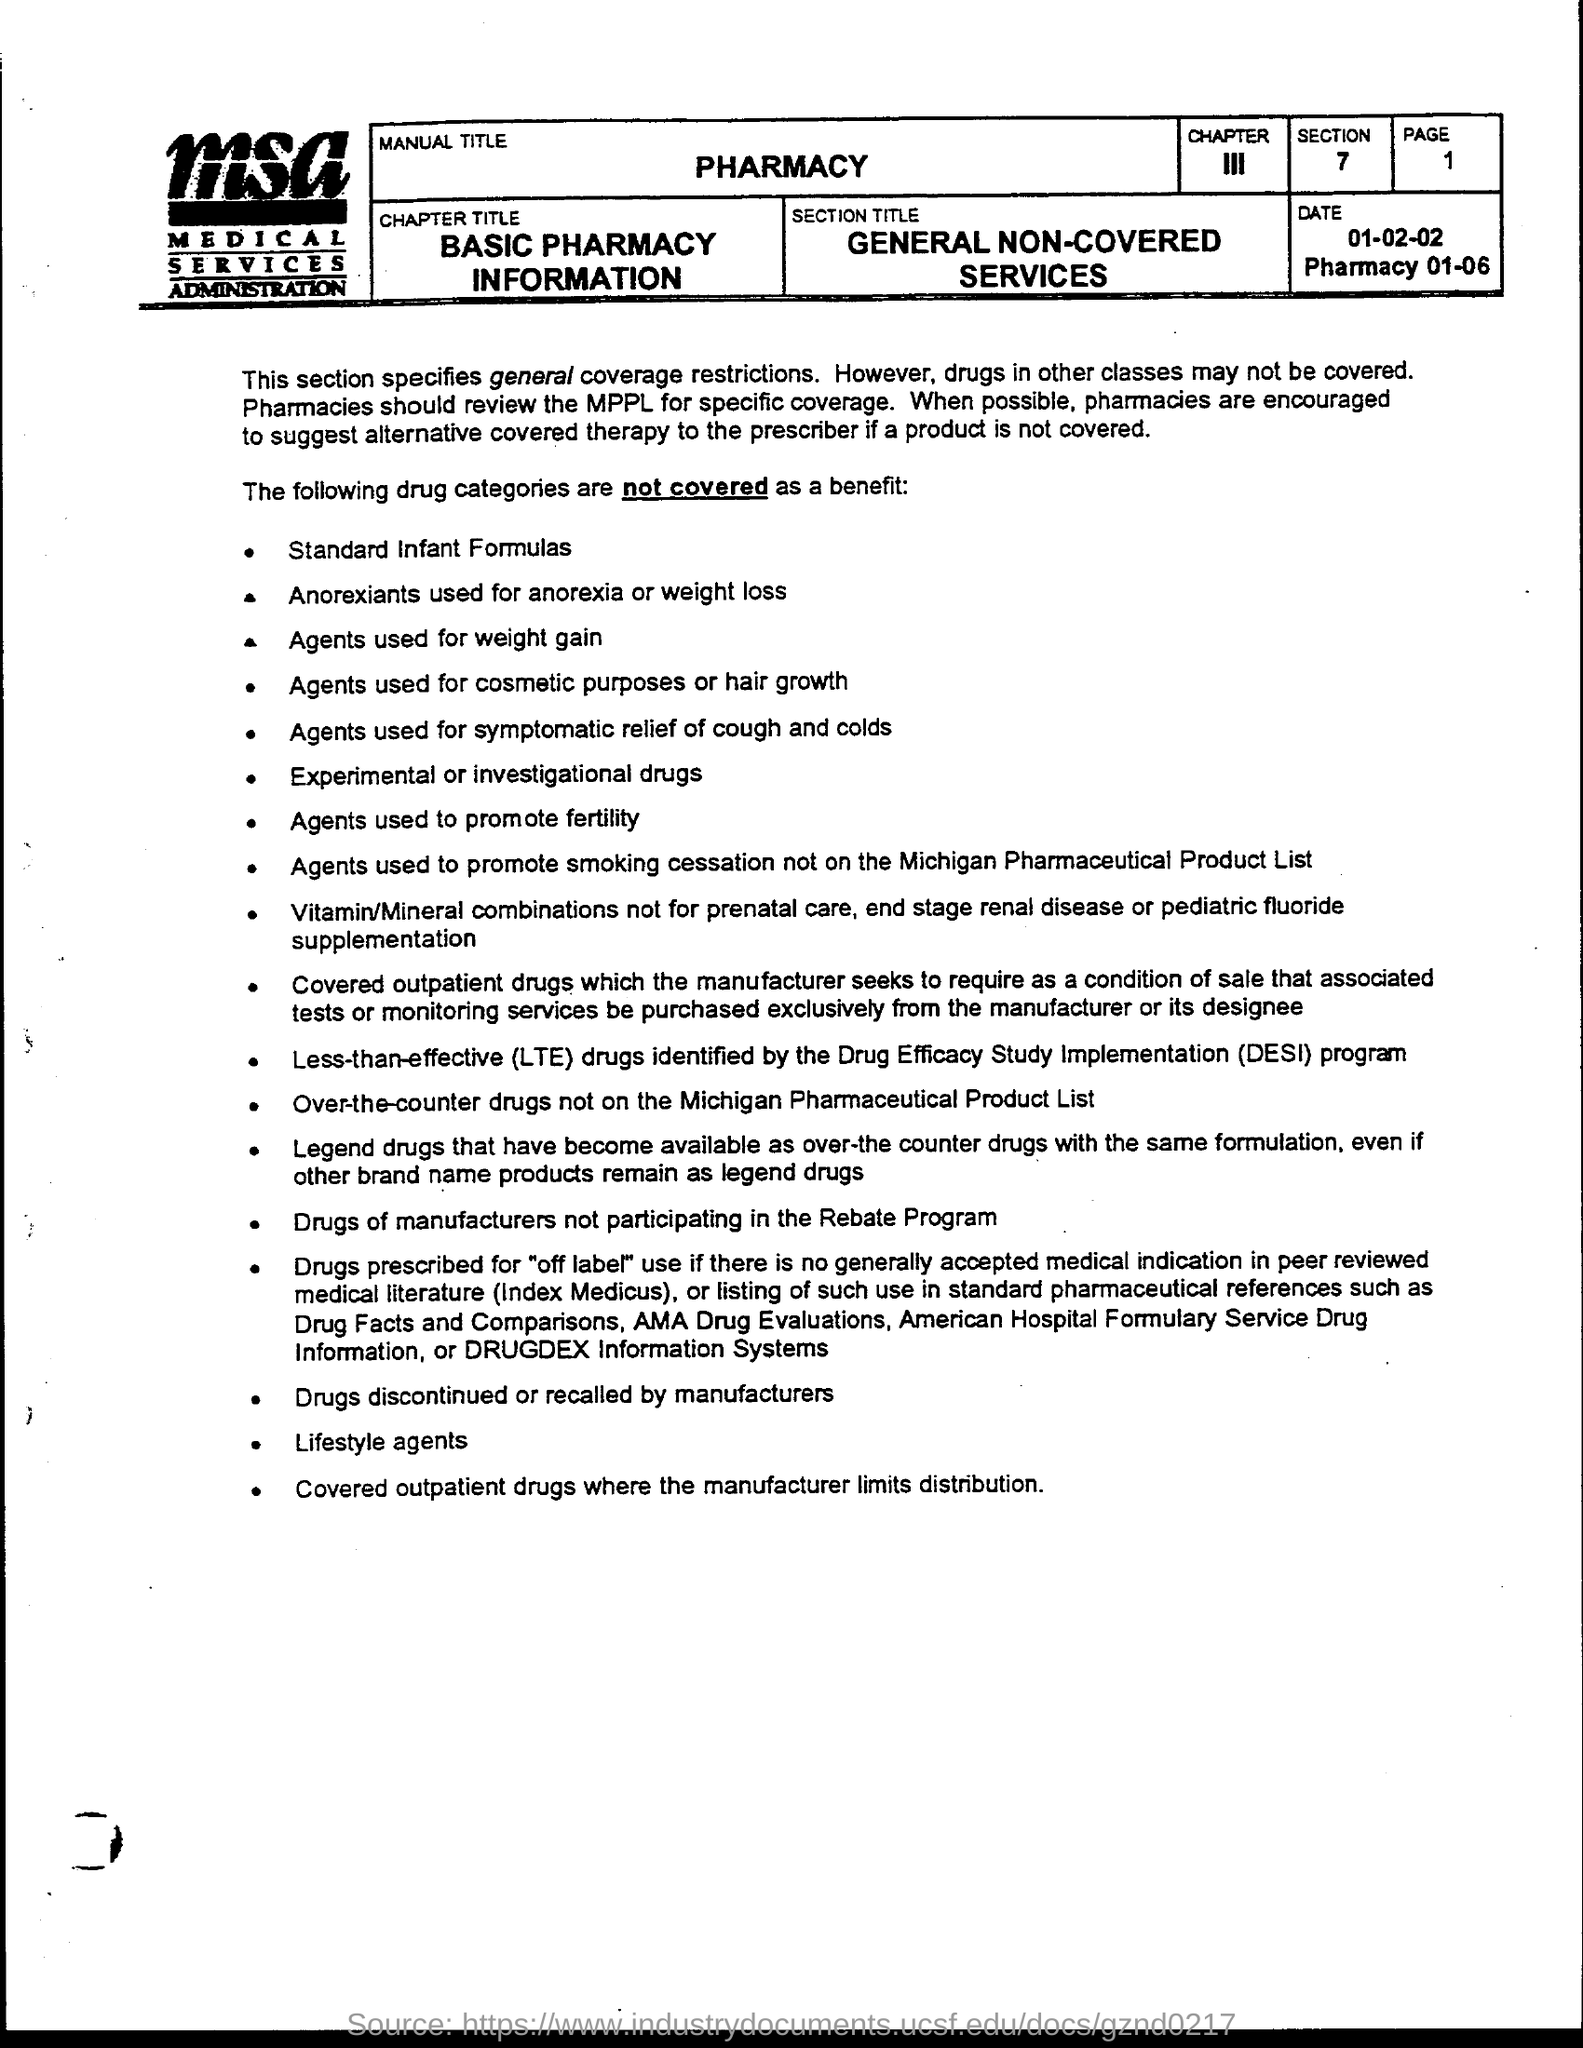What does MSA stand for?
Your response must be concise. Medical Services Administration. What is the Manual Title?
Keep it short and to the point. Pharmacy. What is the Chapter Title?
Offer a terse response. Basic Pharmacy Information. What is the date?
Provide a short and direct response. 01-02-02. What is the page number?
Your response must be concise. 1. What is the section?
Your answer should be compact. 7. 